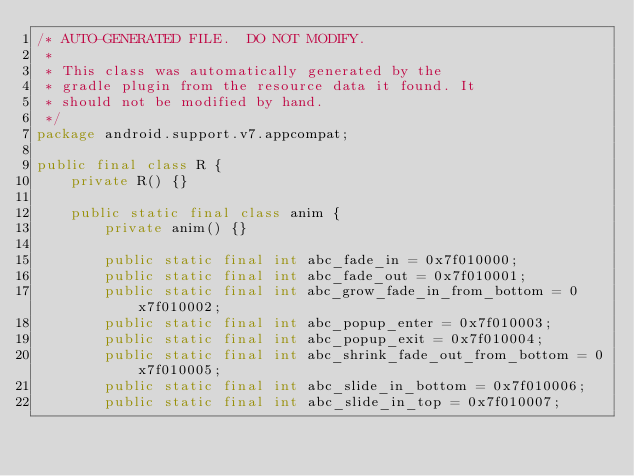Convert code to text. <code><loc_0><loc_0><loc_500><loc_500><_Java_>/* AUTO-GENERATED FILE.  DO NOT MODIFY.
 *
 * This class was automatically generated by the
 * gradle plugin from the resource data it found. It
 * should not be modified by hand.
 */
package android.support.v7.appcompat;

public final class R {
    private R() {}

    public static final class anim {
        private anim() {}

        public static final int abc_fade_in = 0x7f010000;
        public static final int abc_fade_out = 0x7f010001;
        public static final int abc_grow_fade_in_from_bottom = 0x7f010002;
        public static final int abc_popup_enter = 0x7f010003;
        public static final int abc_popup_exit = 0x7f010004;
        public static final int abc_shrink_fade_out_from_bottom = 0x7f010005;
        public static final int abc_slide_in_bottom = 0x7f010006;
        public static final int abc_slide_in_top = 0x7f010007;</code> 